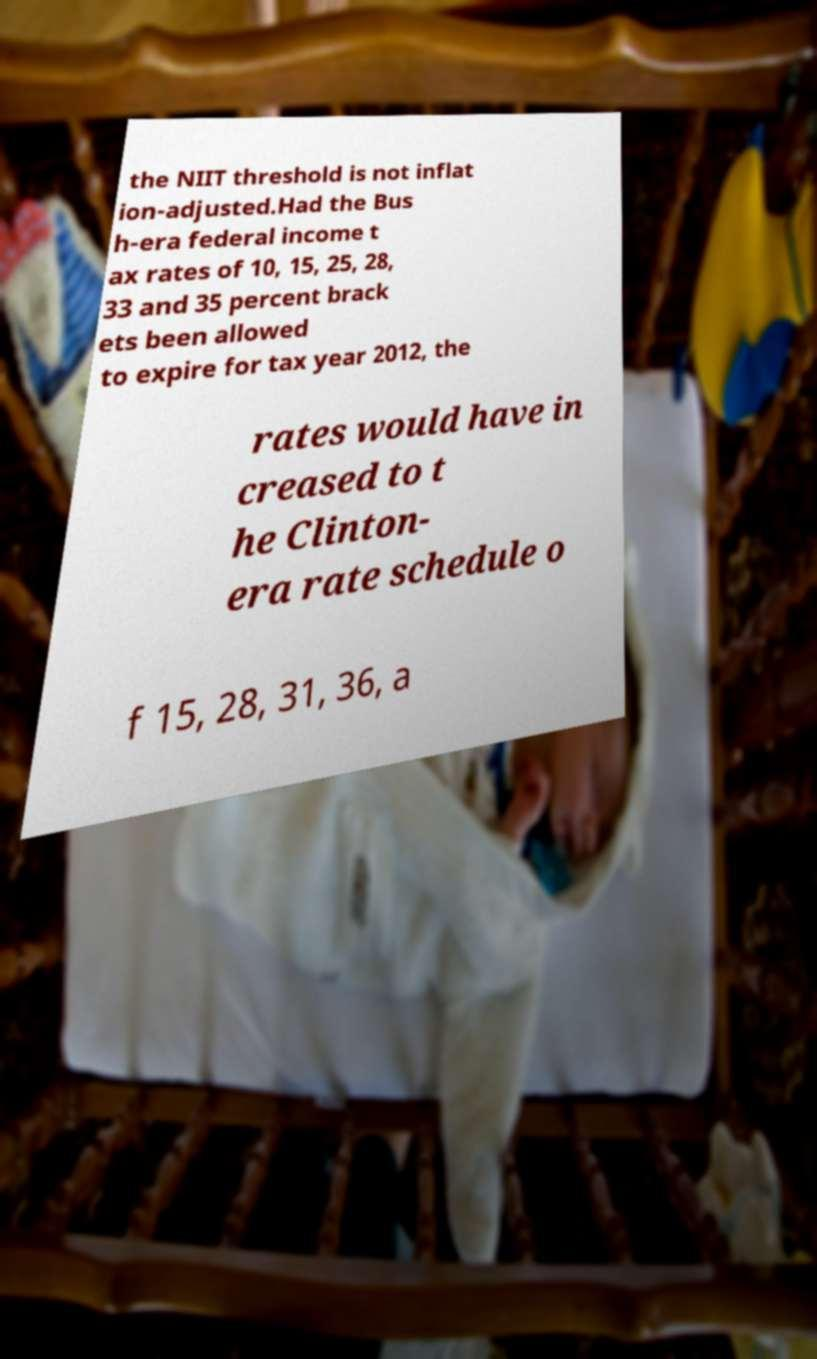Please identify and transcribe the text found in this image. the NIIT threshold is not inflat ion-adjusted.Had the Bus h-era federal income t ax rates of 10, 15, 25, 28, 33 and 35 percent brack ets been allowed to expire for tax year 2012, the rates would have in creased to t he Clinton- era rate schedule o f 15, 28, 31, 36, a 